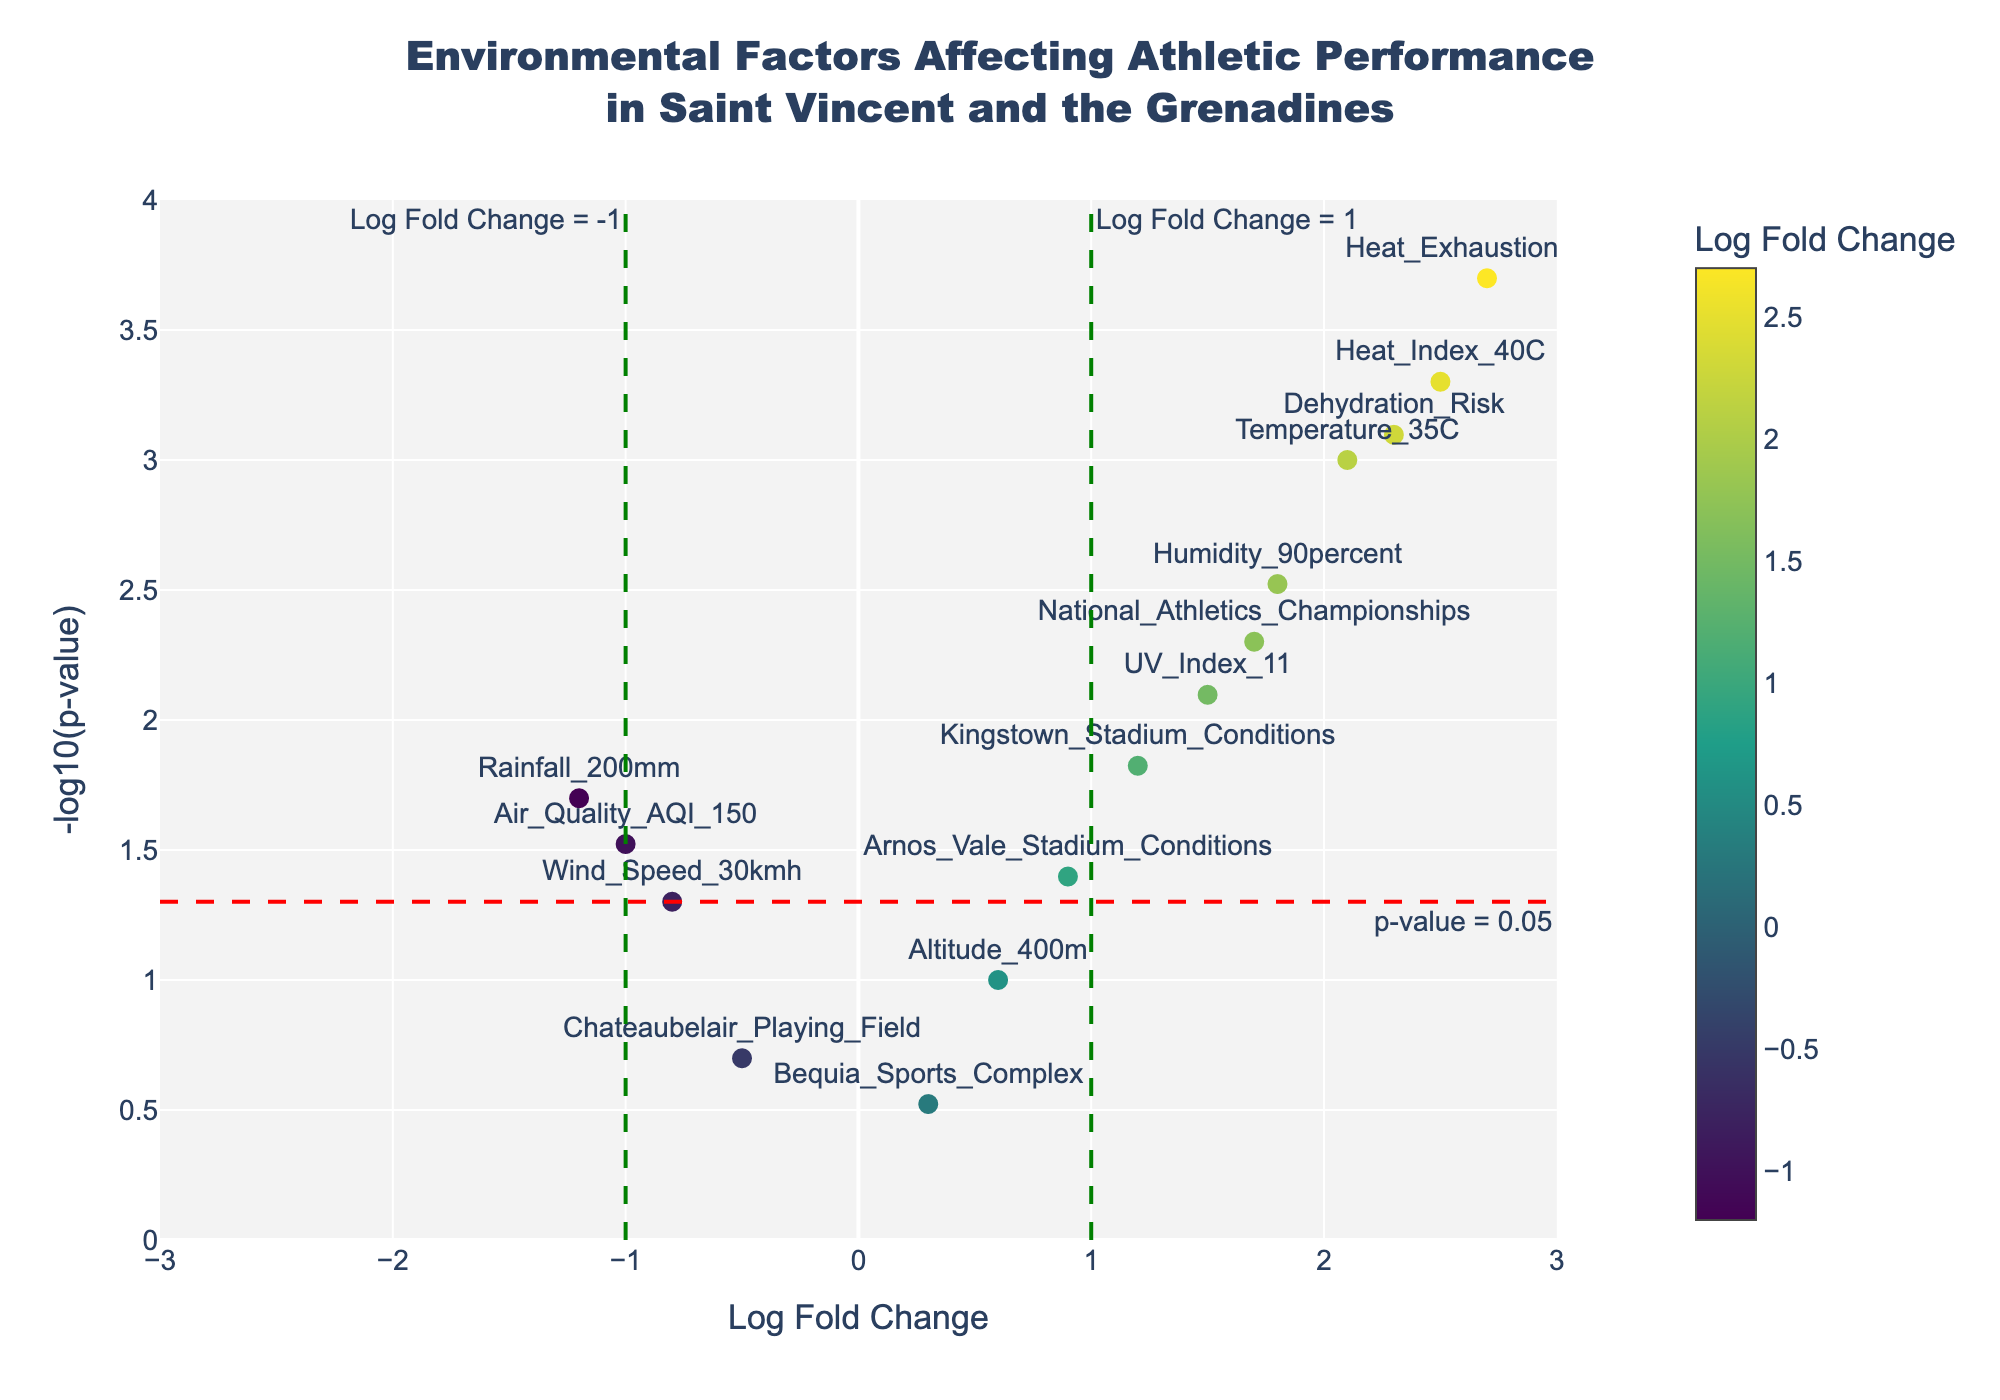What is the title of the figure? The title is usually located at the top of the figure. In this plot, it reads as 'Environmental Factors Affecting Athletic Performance in Saint Vincent and the Grenadines'.
Answer: Environmental Factors Affecting Athletic Performance in Saint Vincent and the Grenadines How many environmental variables have a Log Fold Change greater than 1? By looking at the x-axis, we can count the number of data points that are positioned to the right of the vertical line at Log Fold Change = 1. These points include Temperature_35C, Heat_Index_40C, Dehydration_Risk, Heat_Exhaustion_Risk. These total to 4 points.
Answer: 4 Which environmental variable is associated with the highest -log10(p-value)? To determine this, one should look for the highest point on the y-axis. The point corresponding to the highest -log10(p-value) is Heat_Exhaustion_Risk.
Answer: Heat_Exhaustion_Risk What is the Log Fold Change and p-value of Air_Quality_AQI_150? Locate the Air_Quality_AQI_150 point on the plot. The hover text shows 'Log Fold Change: -1.00' and 'p-value: 0.0300'.
Answer: Log Fold Change: -1.00, p-value: 0.0300 Which environmental variable associated with the smallest -log10(p-value)? The smallest -log10(p-value) corresponds to the lowest point on the y-axis. The point located at the bottom is Chateaubelair_Playing_Field.
Answer: Chateaubelair_Playing_Field Are there any environmental variables with Log Fold Changes between -1 and 1 and significant p-values (<0.05)? By focusing on the region between -1 and 1 on the x-axis and below the horizontal line at -log10(p-value) = 1.301 (p-value = 0.05), we find the points representing Kingstown_Stadium_Conditions and Arnos_Vale_Stadium_Conditions.
Answer: Kingstown_Stadium_Conditions, Arnos_Vale_Stadium_Conditions Which environmental factors have a negative Log Fold Change and significant p-values? Negative Log Fold Changes are to the left of the y-axis. Significant p-values are above the horizontal line. The points representing Rainfall_200mm and Air_Quality_AQI_150 meet these criteria.
Answer: Rainfall_200mm, Air_Quality_AQI_150 What does the green vertical line at Log Fold Change = 1 represent? The green vertical line is an indicator for a Log Fold Change threshold of 1, typically representing a notable increase in effect.
Answer: Log Fold Change = 1 threshold Name the environmental variables with the highest positive and highest negative Log Fold Change. The highest positive Log Fold Change is Heat_Exhaustion_Risk (2.7), and the highest negative Log Fold Change is Rainfall_200mm (-1.2).
Answer: Heat_Exhaustion_Risk, Rainfall_200mm 